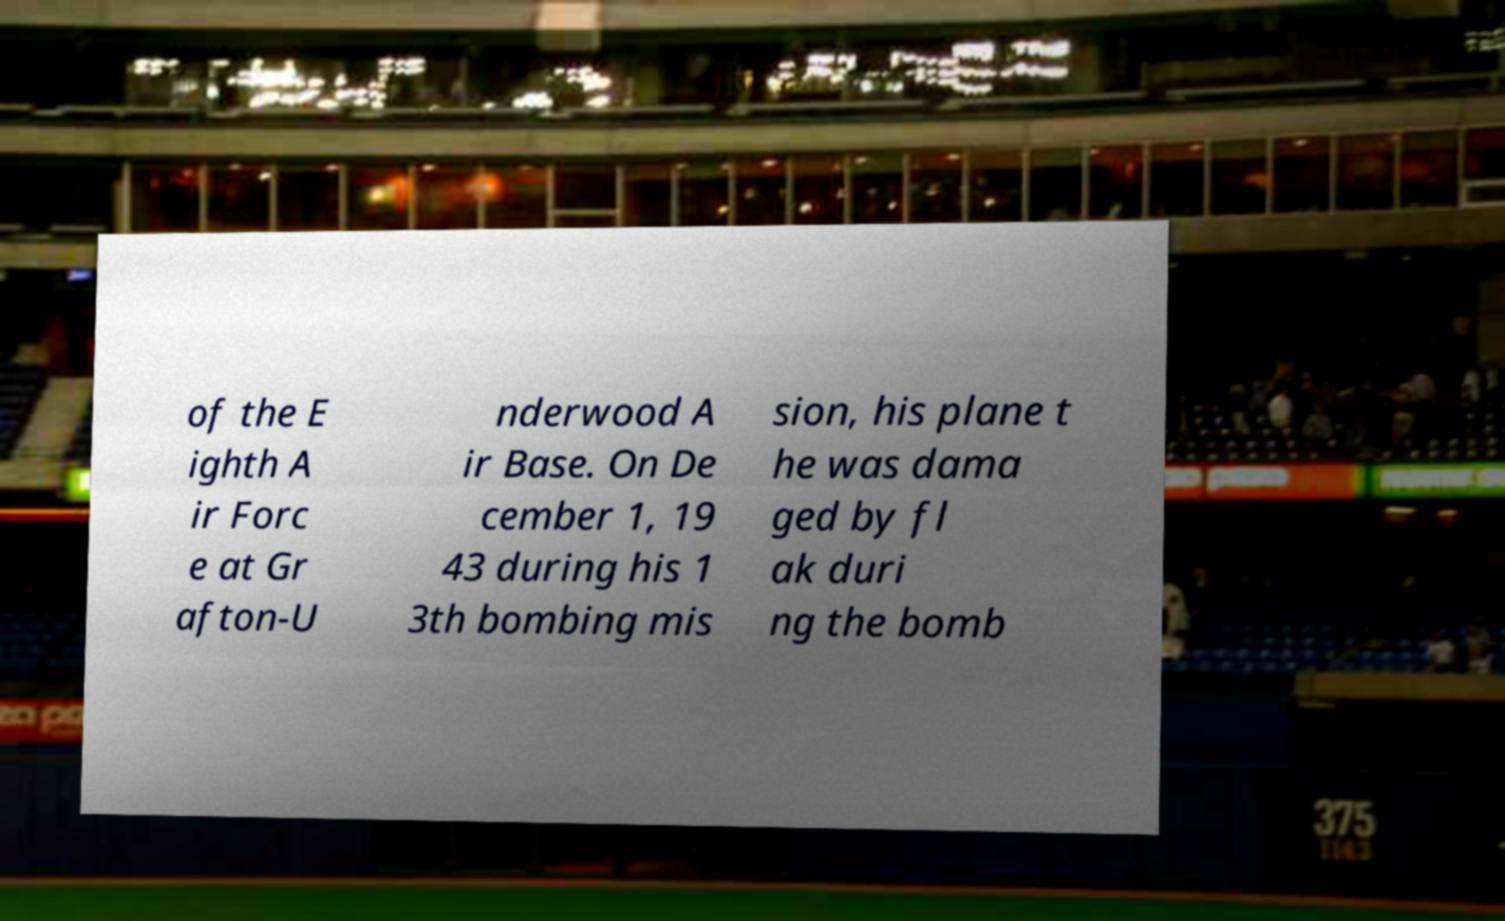Can you accurately transcribe the text from the provided image for me? of the E ighth A ir Forc e at Gr afton-U nderwood A ir Base. On De cember 1, 19 43 during his 1 3th bombing mis sion, his plane t he was dama ged by fl ak duri ng the bomb 